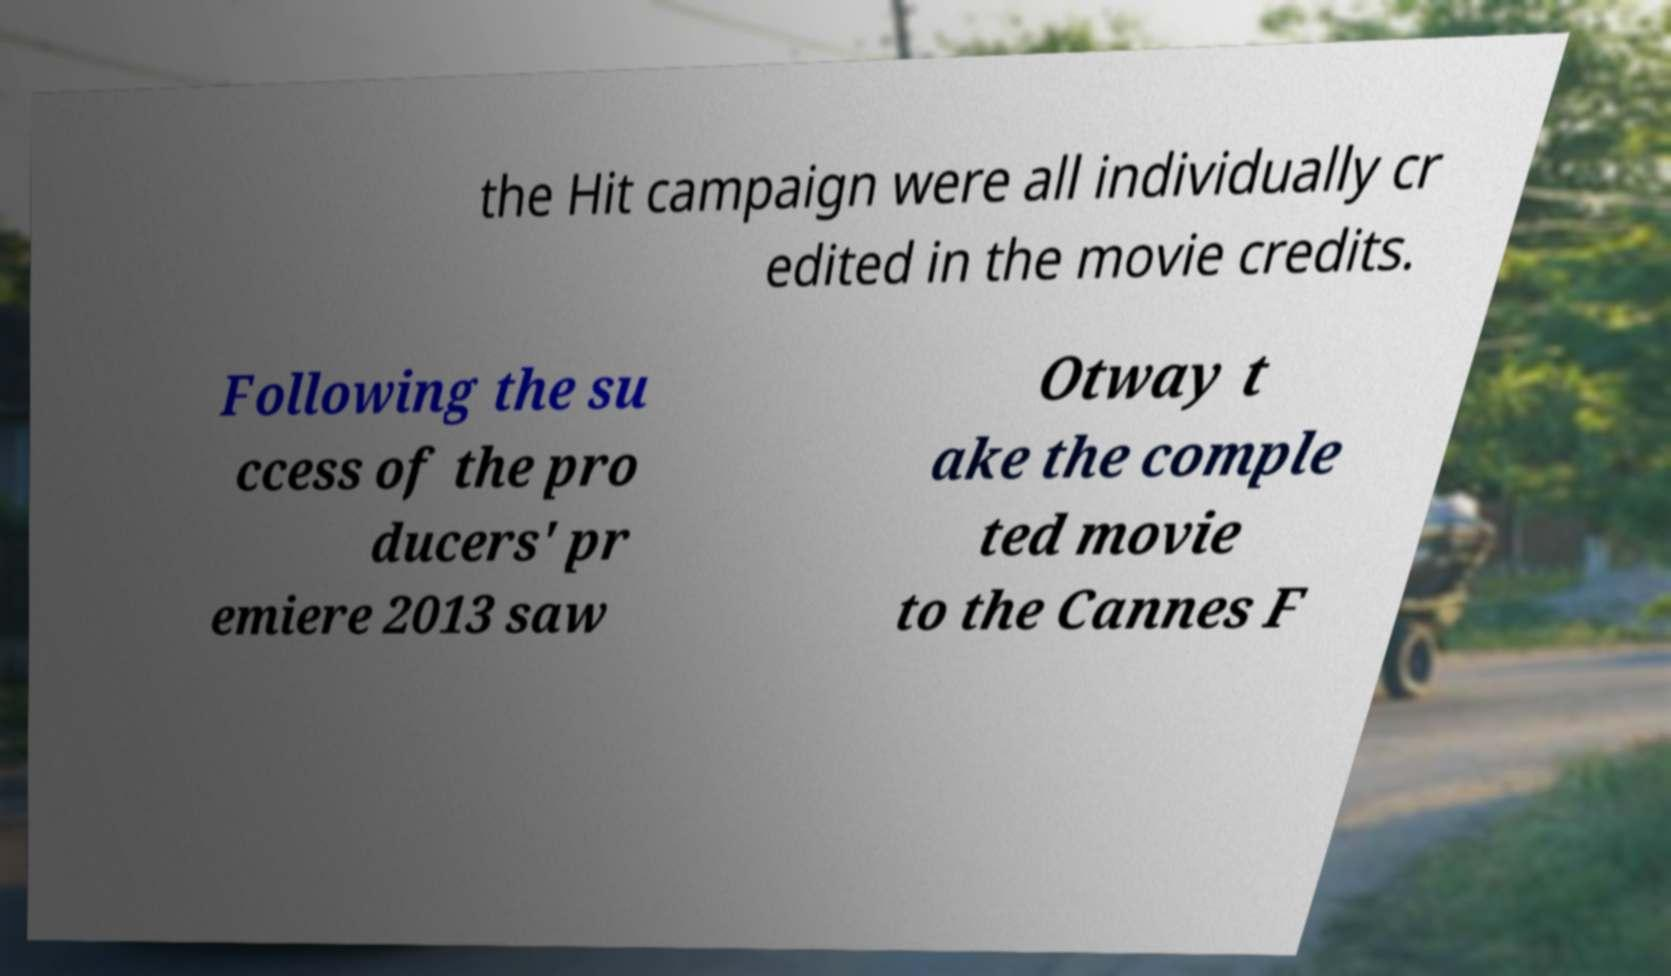What messages or text are displayed in this image? I need them in a readable, typed format. the Hit campaign were all individually cr edited in the movie credits. Following the su ccess of the pro ducers' pr emiere 2013 saw Otway t ake the comple ted movie to the Cannes F 